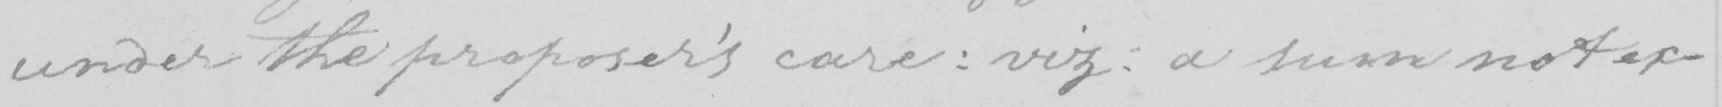Please provide the text content of this handwritten line. under the proposer ' s care  :  viz  :  a sum not ex- 